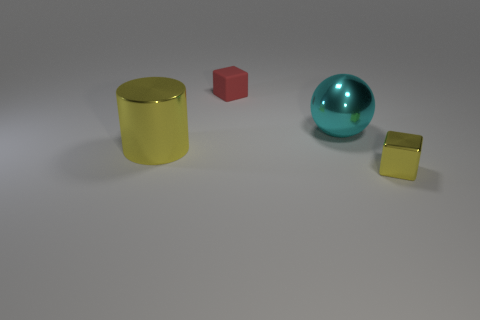Add 2 tiny cyan rubber things. How many objects exist? 6 Subtract all cylinders. How many objects are left? 3 Add 3 red rubber blocks. How many red rubber blocks are left? 4 Add 4 yellow cylinders. How many yellow cylinders exist? 5 Subtract 0 gray balls. How many objects are left? 4 Subtract all small red objects. Subtract all gray rubber objects. How many objects are left? 3 